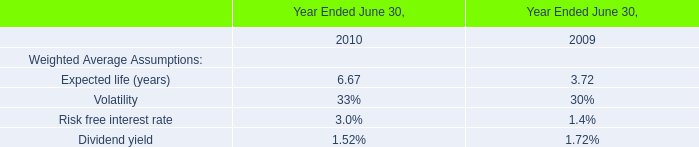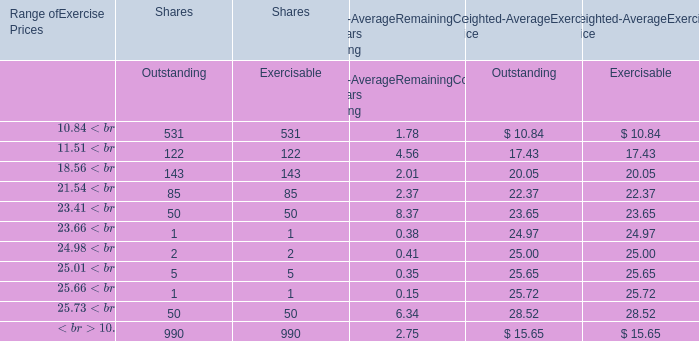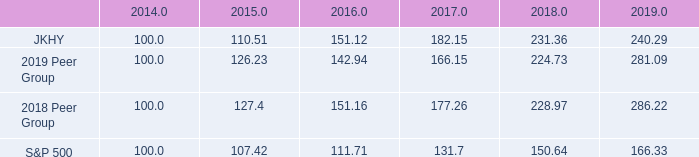What's the sum of all Exercisable that are greater than 100 for Shares？ 
Computations: ((531 + 122) + 143)
Answer: 796.0. 